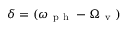<formula> <loc_0><loc_0><loc_500><loc_500>\delta = ( \omega _ { p h } - \Omega _ { v } )</formula> 